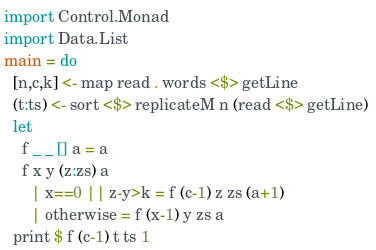Convert code to text. <code><loc_0><loc_0><loc_500><loc_500><_Haskell_>import Control.Monad
import Data.List
main = do
  [n,c,k] <- map read . words <$> getLine
  (t:ts) <- sort <$> replicateM n (read <$> getLine) 
  let 
    f _ _ [] a = a
    f x y (z:zs) a
      | x==0 || z-y>k = f (c-1) z zs (a+1)
      | otherwise = f (x-1) y zs a
  print $ f (c-1) t ts 1</code> 